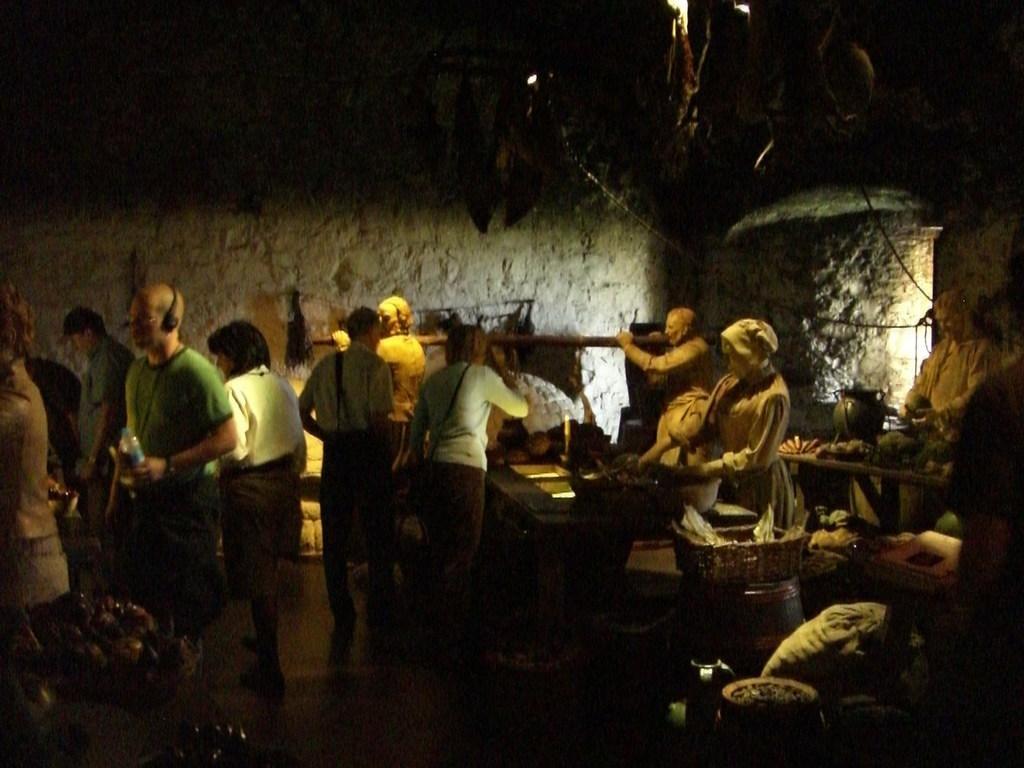Please provide a concise description of this image. In this picture we can see few people are standing on the path. We can see some fruits on the table. There is a basket and few things in it. We can see a bag. There is a light on top. 